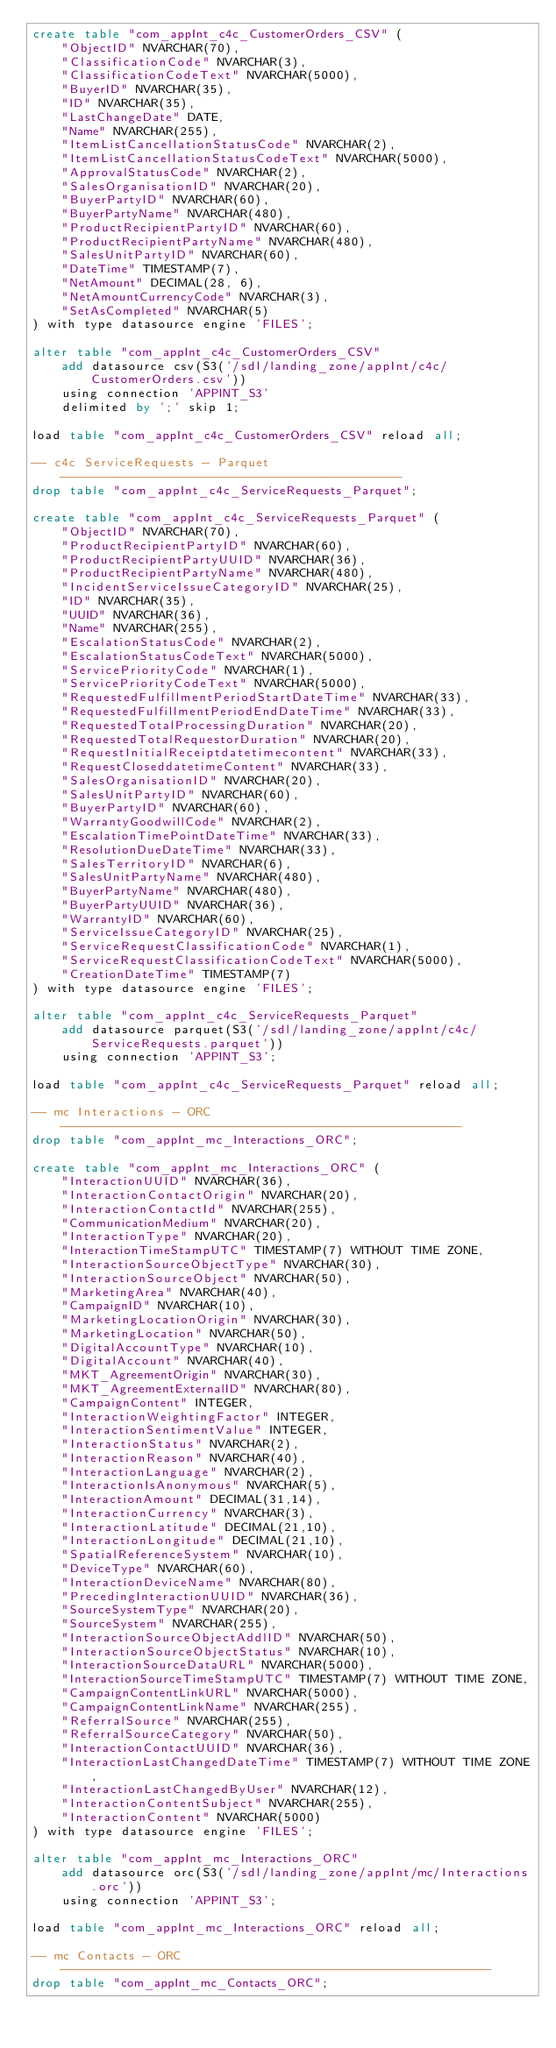Convert code to text. <code><loc_0><loc_0><loc_500><loc_500><_SQL_>create table "com_appInt_c4c_CustomerOrders_CSV" (
	"ObjectID" NVARCHAR(70),
	"ClassificationCode" NVARCHAR(3),
	"ClassificationCodeText" NVARCHAR(5000),
	"BuyerID" NVARCHAR(35),
	"ID" NVARCHAR(35),
	"LastChangeDate" DATE,
	"Name" NVARCHAR(255),
	"ItemListCancellationStatusCode" NVARCHAR(2),
	"ItemListCancellationStatusCodeText" NVARCHAR(5000),
	"ApprovalStatusCode" NVARCHAR(2),
	"SalesOrganisationID" NVARCHAR(20),
	"BuyerPartyID" NVARCHAR(60),
	"BuyerPartyName" NVARCHAR(480),
	"ProductRecipientPartyID" NVARCHAR(60),
	"ProductRecipientPartyName" NVARCHAR(480),
	"SalesUnitPartyID" NVARCHAR(60),
	"DateTime" TIMESTAMP(7),
	"NetAmount" DECIMAL(28, 6),
	"NetAmountCurrencyCode" NVARCHAR(3),
	"SetAsCompleted" NVARCHAR(5)
) with type datasource engine 'FILES';

alter table "com_appInt_c4c_CustomerOrders_CSV"
    add datasource csv(S3('/sdl/landing_zone/appInt/c4c/CustomerOrders.csv')) 
    using connection 'APPINT_S3'
    delimited by ';' skip 1;

load table "com_appInt_c4c_CustomerOrders_CSV" reload all;

-- c4c ServiceRequests - Parquet ----------------------------------------------
drop table "com_appInt_c4c_ServiceRequests_Parquet";

create table "com_appInt_c4c_ServiceRequests_Parquet" (
	"ObjectID" NVARCHAR(70),
	"ProductRecipientPartyID" NVARCHAR(60),
	"ProductRecipientPartyUUID" NVARCHAR(36),
	"ProductRecipientPartyName" NVARCHAR(480),
	"IncidentServiceIssueCategoryID" NVARCHAR(25),
	"ID" NVARCHAR(35),
	"UUID" NVARCHAR(36),
	"Name" NVARCHAR(255),
	"EscalationStatusCode" NVARCHAR(2),
	"EscalationStatusCodeText" NVARCHAR(5000),
	"ServicePriorityCode" NVARCHAR(1),
	"ServicePriorityCodeText" NVARCHAR(5000),
	"RequestedFulfillmentPeriodStartDateTime" NVARCHAR(33),
	"RequestedFulfillmentPeriodEndDateTime" NVARCHAR(33),
	"RequestedTotalProcessingDuration" NVARCHAR(20),
	"RequestedTotalRequestorDuration" NVARCHAR(20),
	"RequestInitialReceiptdatetimecontent" NVARCHAR(33),
	"RequestCloseddatetimeContent" NVARCHAR(33),
	"SalesOrganisationID" NVARCHAR(20),
	"SalesUnitPartyID" NVARCHAR(60),
	"BuyerPartyID" NVARCHAR(60),
	"WarrantyGoodwillCode" NVARCHAR(2),
	"EscalationTimePointDateTime" NVARCHAR(33),
	"ResolutionDueDateTime" NVARCHAR(33),
	"SalesTerritoryID" NVARCHAR(6),
	"SalesUnitPartyName" NVARCHAR(480),
	"BuyerPartyName" NVARCHAR(480),
	"BuyerPartyUUID" NVARCHAR(36),
	"WarrantyID" NVARCHAR(60),
	"ServiceIssueCategoryID" NVARCHAR(25),
	"ServiceRequestClassificationCode" NVARCHAR(1),
	"ServiceRequestClassificationCodeText" NVARCHAR(5000),
	"CreationDateTime" TIMESTAMP(7)
) with type datasource engine 'FILES';

alter table "com_appInt_c4c_ServiceRequests_Parquet"
    add datasource parquet(S3('/sdl/landing_zone/appInt/c4c/ServiceRequests.parquet')) 
    using connection 'APPINT_S3';

load table "com_appInt_c4c_ServiceRequests_Parquet" reload all;

-- mc Interactions - ORC ------------------------------------------------------
drop table "com_appInt_mc_Interactions_ORC";

create table "com_appInt_mc_Interactions_ORC" (
	"InteractionUUID" NVARCHAR(36),
	"InteractionContactOrigin" NVARCHAR(20),
	"InteractionContactId" NVARCHAR(255),
	"CommunicationMedium" NVARCHAR(20),
	"InteractionType" NVARCHAR(20),
	"InteractionTimeStampUTC" TIMESTAMP(7) WITHOUT TIME ZONE,
	"InteractionSourceObjectType" NVARCHAR(30),
	"InteractionSourceObject" NVARCHAR(50),
	"MarketingArea" NVARCHAR(40),
	"CampaignID" NVARCHAR(10),
	"MarketingLocationOrigin" NVARCHAR(30),
	"MarketingLocation" NVARCHAR(50),
	"DigitalAccountType" NVARCHAR(10),
	"DigitalAccount" NVARCHAR(40),
	"MKT_AgreementOrigin" NVARCHAR(30),
	"MKT_AgreementExternalID" NVARCHAR(80),
	"CampaignContent" INTEGER,
	"InteractionWeightingFactor" INTEGER,
	"InteractionSentimentValue" INTEGER,
	"InteractionStatus" NVARCHAR(2),
	"InteractionReason" NVARCHAR(40),
	"InteractionLanguage" NVARCHAR(2),
	"InteractionIsAnonymous" NVARCHAR(5),
	"InteractionAmount" DECIMAL(31,14),
	"InteractionCurrency" NVARCHAR(3),
	"InteractionLatitude" DECIMAL(21,10),
	"InteractionLongitude" DECIMAL(21,10),
	"SpatialReferenceSystem" NVARCHAR(10),
	"DeviceType" NVARCHAR(60),
	"InteractionDeviceName" NVARCHAR(80),
	"PrecedingInteractionUUID" NVARCHAR(36),
	"SourceSystemType" NVARCHAR(20),
	"SourceSystem" NVARCHAR(255),
	"InteractionSourceObjectAddlID" NVARCHAR(50),
	"InteractionSourceObjectStatus" NVARCHAR(10),
	"InteractionSourceDataURL" NVARCHAR(5000),
	"InteractionSourceTimeStampUTC" TIMESTAMP(7) WITHOUT TIME ZONE,
	"CampaignContentLinkURL" NVARCHAR(5000),
	"CampaignContentLinkName" NVARCHAR(255),
	"ReferralSource" NVARCHAR(255),
	"ReferralSourceCategory" NVARCHAR(50),
	"InteractionContactUUID" NVARCHAR(36),
	"InteractionLastChangedDateTime" TIMESTAMP(7) WITHOUT TIME ZONE,
	"InteractionLastChangedByUser" NVARCHAR(12),
	"InteractionContentSubject" NVARCHAR(255),
	"InteractionContent" NVARCHAR(5000)
) with type datasource engine 'FILES';

alter table "com_appInt_mc_Interactions_ORC"
    add datasource orc(S3('/sdl/landing_zone/appInt/mc/Interactions.orc')) 
    using connection 'APPINT_S3';

load table "com_appInt_mc_Interactions_ORC" reload all;

-- mc Contacts - ORC ----------------------------------------------------------
drop table "com_appInt_mc_Contacts_ORC";
</code> 